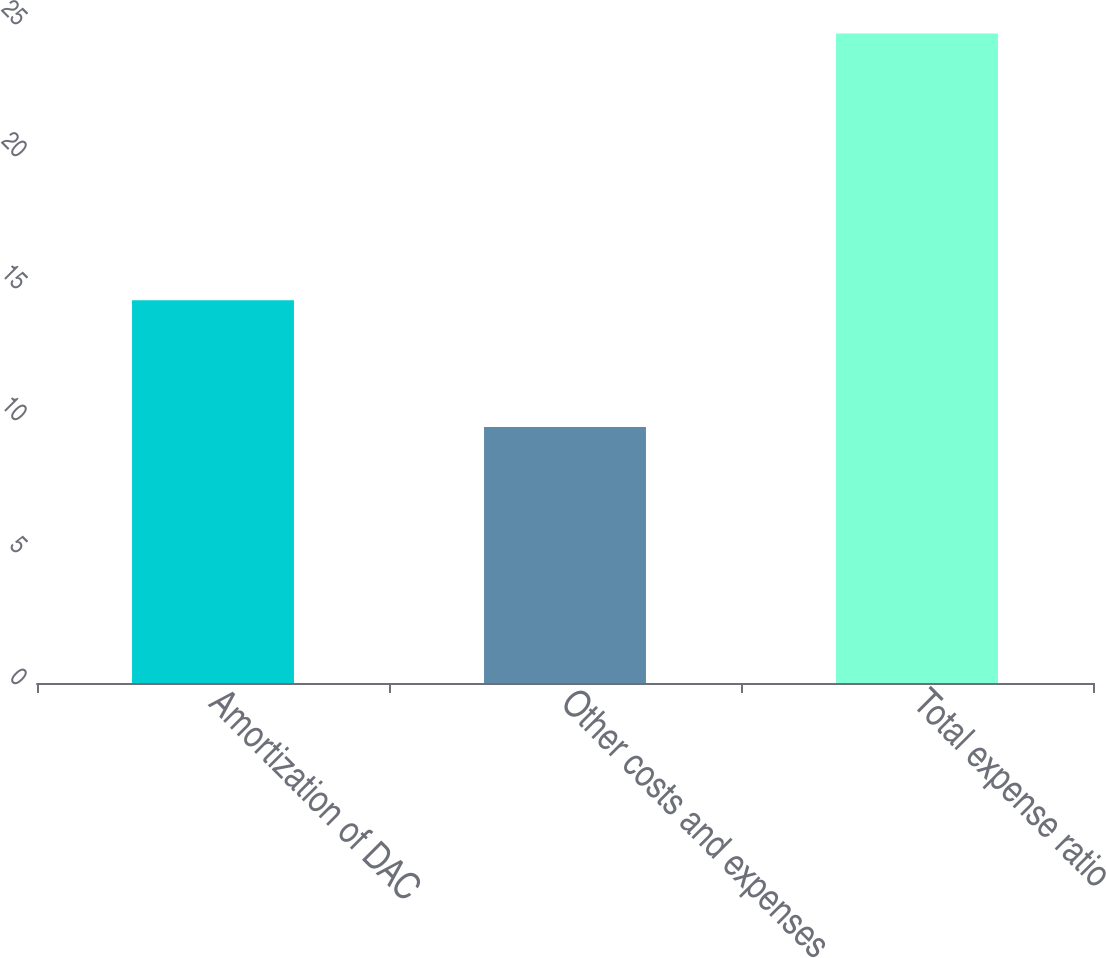Convert chart to OTSL. <chart><loc_0><loc_0><loc_500><loc_500><bar_chart><fcel>Amortization of DAC<fcel>Other costs and expenses<fcel>Total expense ratio<nl><fcel>14.5<fcel>9.7<fcel>24.6<nl></chart> 